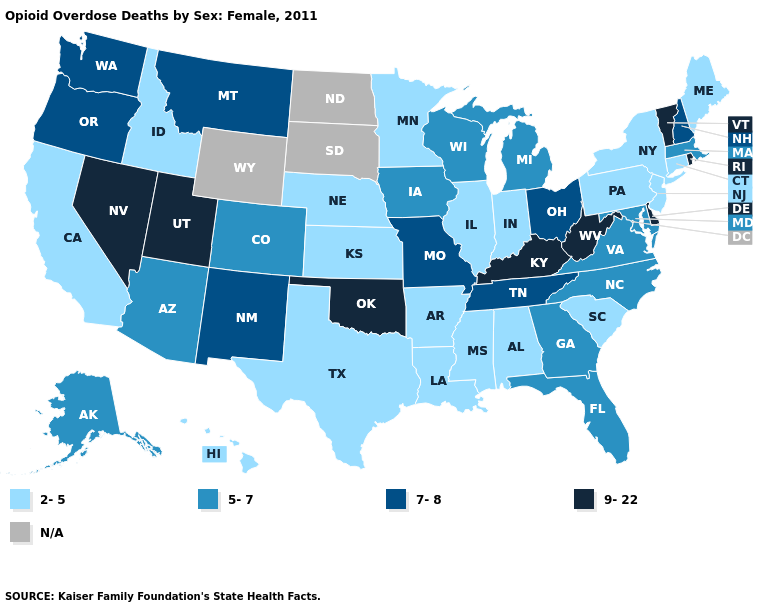What is the value of Alabama?
Be succinct. 2-5. Which states have the lowest value in the South?
Be succinct. Alabama, Arkansas, Louisiana, Mississippi, South Carolina, Texas. Does the map have missing data?
Concise answer only. Yes. Does Oklahoma have the highest value in the South?
Write a very short answer. Yes. Does the first symbol in the legend represent the smallest category?
Quick response, please. Yes. What is the highest value in states that border Iowa?
Short answer required. 7-8. Does the first symbol in the legend represent the smallest category?
Give a very brief answer. Yes. Name the states that have a value in the range 5-7?
Answer briefly. Alaska, Arizona, Colorado, Florida, Georgia, Iowa, Maryland, Massachusetts, Michigan, North Carolina, Virginia, Wisconsin. Name the states that have a value in the range 5-7?
Short answer required. Alaska, Arizona, Colorado, Florida, Georgia, Iowa, Maryland, Massachusetts, Michigan, North Carolina, Virginia, Wisconsin. Name the states that have a value in the range 5-7?
Concise answer only. Alaska, Arizona, Colorado, Florida, Georgia, Iowa, Maryland, Massachusetts, Michigan, North Carolina, Virginia, Wisconsin. What is the highest value in the West ?
Answer briefly. 9-22. What is the value of Tennessee?
Answer briefly. 7-8. What is the lowest value in states that border Arizona?
Quick response, please. 2-5. Does Delaware have the highest value in the USA?
Answer briefly. Yes. Name the states that have a value in the range 9-22?
Answer briefly. Delaware, Kentucky, Nevada, Oklahoma, Rhode Island, Utah, Vermont, West Virginia. 